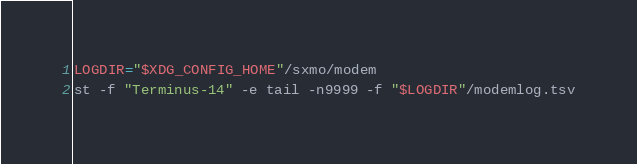<code> <loc_0><loc_0><loc_500><loc_500><_Bash_>LOGDIR="$XDG_CONFIG_HOME"/sxmo/modem
st -f "Terminus-14" -e tail -n9999 -f "$LOGDIR"/modemlog.tsv
</code> 